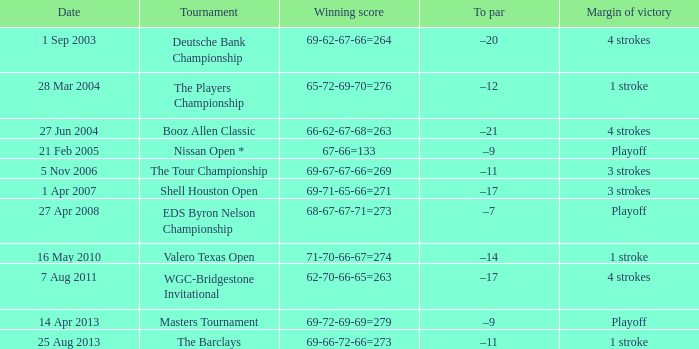Which date has a To par of –12? 28 Mar 2004. Would you be able to parse every entry in this table? {'header': ['Date', 'Tournament', 'Winning score', 'To par', 'Margin of victory'], 'rows': [['1 Sep 2003', 'Deutsche Bank Championship', '69-62-67-66=264', '–20', '4 strokes'], ['28 Mar 2004', 'The Players Championship', '65-72-69-70=276', '–12', '1 stroke'], ['27 Jun 2004', 'Booz Allen Classic', '66-62-67-68=263', '–21', '4 strokes'], ['21 Feb 2005', 'Nissan Open *', '67-66=133', '–9', 'Playoff'], ['5 Nov 2006', 'The Tour Championship', '69-67-67-66=269', '–11', '3 strokes'], ['1 Apr 2007', 'Shell Houston Open', '69-71-65-66=271', '–17', '3 strokes'], ['27 Apr 2008', 'EDS Byron Nelson Championship', '68-67-67-71=273', '–7', 'Playoff'], ['16 May 2010', 'Valero Texas Open', '71-70-66-67=274', '–14', '1 stroke'], ['7 Aug 2011', 'WGC-Bridgestone Invitational', '62-70-66-65=263', '–17', '4 strokes'], ['14 Apr 2013', 'Masters Tournament', '69-72-69-69=279', '–9', 'Playoff'], ['25 Aug 2013', 'The Barclays', '69-66-72-66=273', '–11', '1 stroke']]} 